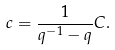Convert formula to latex. <formula><loc_0><loc_0><loc_500><loc_500>c = \frac { 1 } { q ^ { - 1 } - q } C .</formula> 